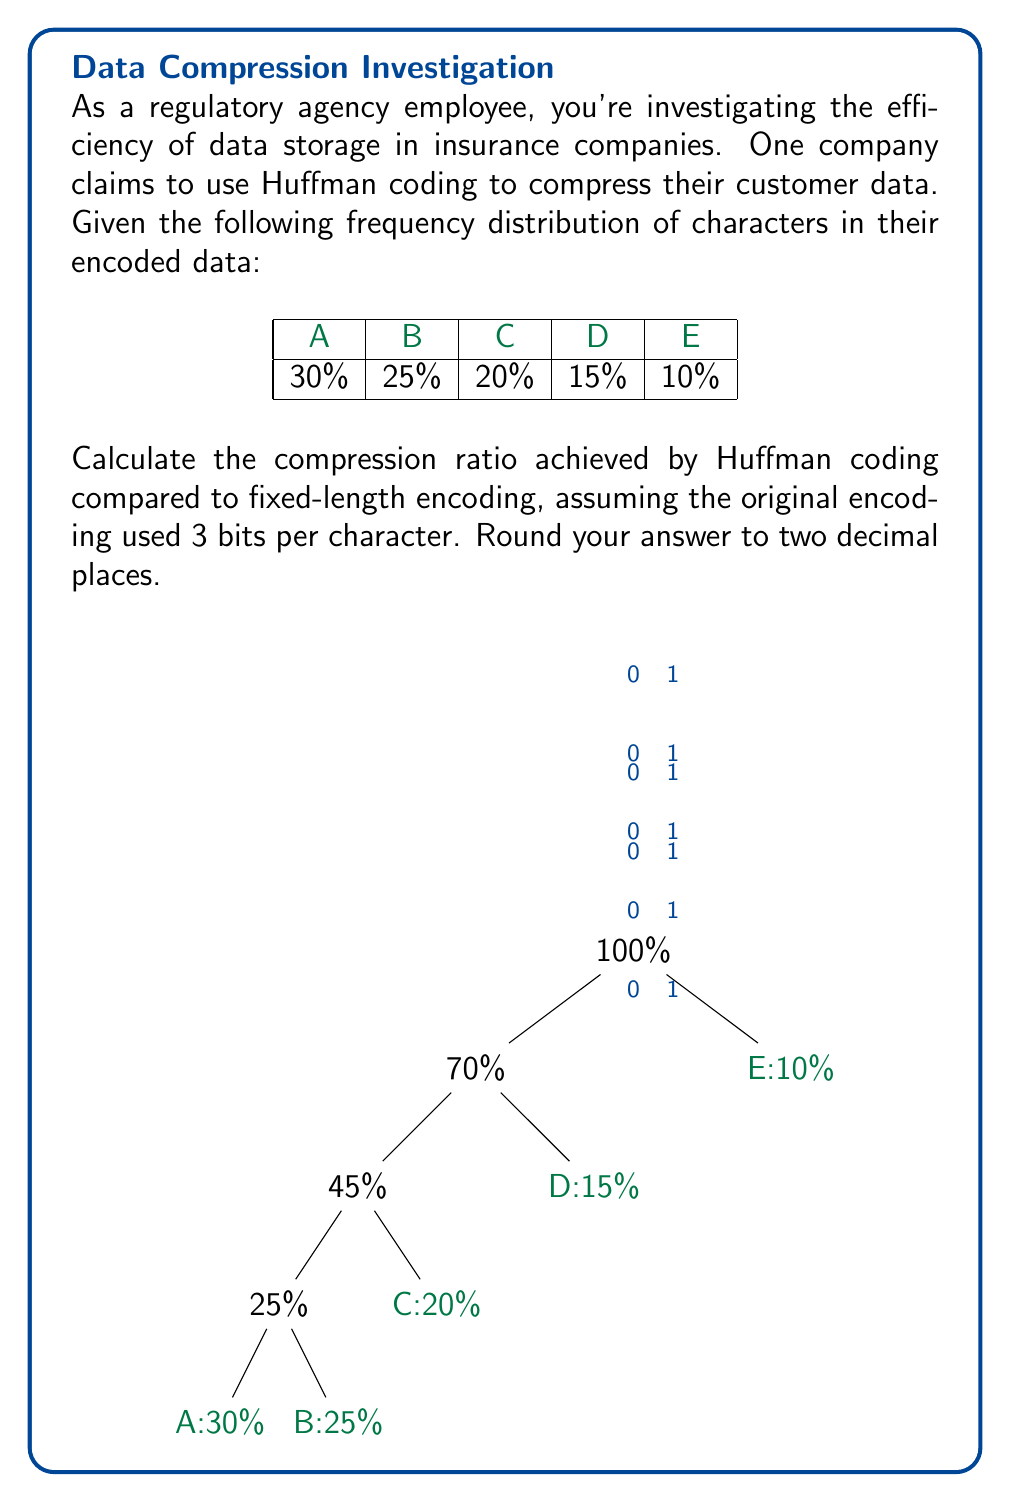Provide a solution to this math problem. Let's approach this step-by-step:

1) First, we need to construct the Huffman tree based on the given frequencies. The tree is shown in the question diagram.

2) From the tree, we can determine the Huffman code for each character:
   A: 0000
   B: 001
   C: 01
   D: 10
   E: 11

3) Now, let's calculate the average number of bits per character in the Huffman coding:

   $$ L_{avg} = 4(0.30) + 3(0.25) + 2(0.20) + 2(0.15) + 2(0.10) = 2.75 \text{ bits} $$

4) The original fixed-length encoding used 3 bits per character.

5) The compression ratio is calculated as:

   $$ \text{Compression Ratio} = \frac{\text{Original Bits}}{\text{Compressed Bits}} = \frac{3}{2.75} $$

6) Calculating this:

   $$ \frac{3}{2.75} \approx 1.0909 $$

7) Rounding to two decimal places: 1.09

Therefore, the compression ratio is 1.09, meaning the Huffman coding achieves about 9% compression compared to the original fixed-length encoding.
Answer: 1.09 